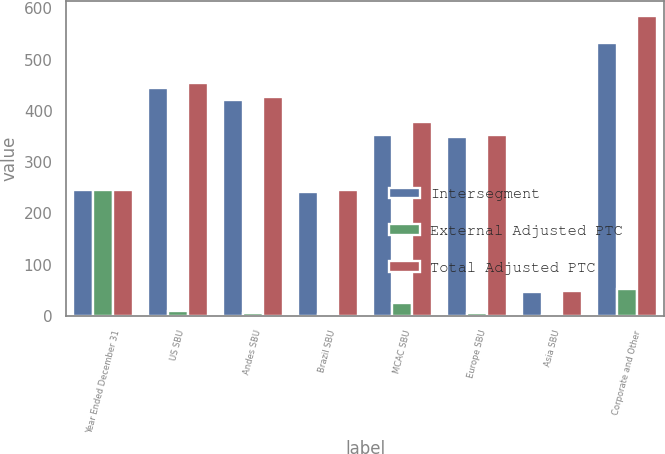Convert chart to OTSL. <chart><loc_0><loc_0><loc_500><loc_500><stacked_bar_chart><ecel><fcel>Year Ended December 31<fcel>US SBU<fcel>Andes SBU<fcel>Brazil SBU<fcel>MCAC SBU<fcel>Europe SBU<fcel>Asia SBU<fcel>Corporate and Other<nl><fcel>Intersegment<fcel>245<fcel>445<fcel>421<fcel>242<fcel>352<fcel>348<fcel>46<fcel>533<nl><fcel>External Adjusted PTC<fcel>245<fcel>10<fcel>6<fcel>3<fcel>26<fcel>5<fcel>2<fcel>52<nl><fcel>Total Adjusted PTC<fcel>245<fcel>455<fcel>427<fcel>245<fcel>378<fcel>353<fcel>48<fcel>585<nl></chart> 